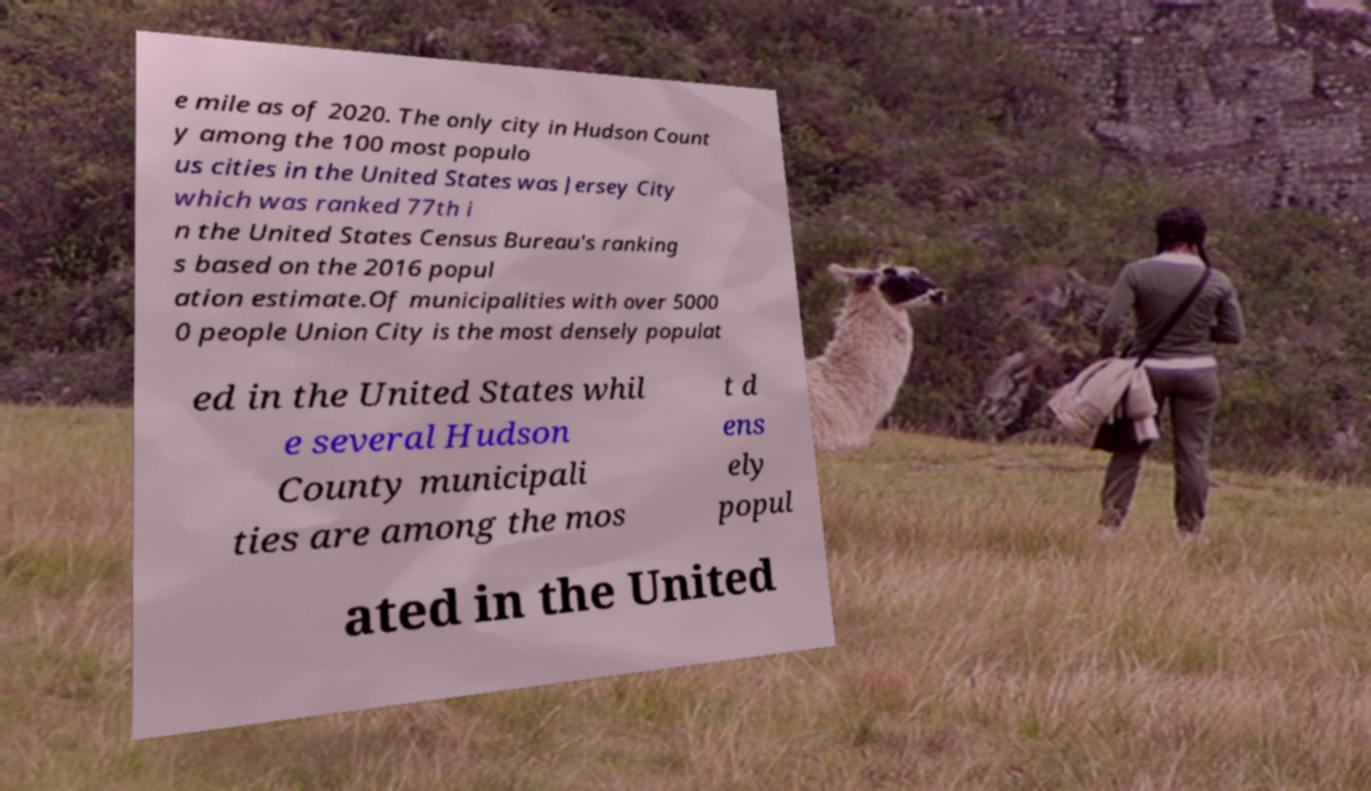Please identify and transcribe the text found in this image. e mile as of 2020. The only city in Hudson Count y among the 100 most populo us cities in the United States was Jersey City which was ranked 77th i n the United States Census Bureau's ranking s based on the 2016 popul ation estimate.Of municipalities with over 5000 0 people Union City is the most densely populat ed in the United States whil e several Hudson County municipali ties are among the mos t d ens ely popul ated in the United 